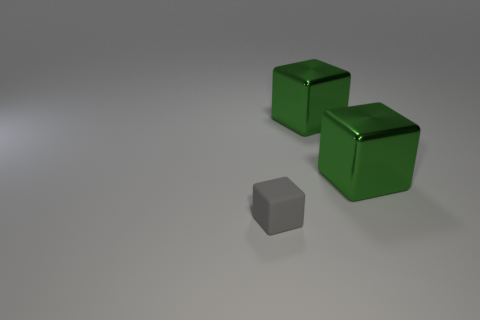Add 3 matte cubes. How many objects exist? 6 Add 2 gray matte blocks. How many gray matte blocks are left? 3 Add 1 tiny gray matte objects. How many tiny gray matte objects exist? 2 Subtract 0 cyan cylinders. How many objects are left? 3 Subtract all rubber things. Subtract all large blocks. How many objects are left? 0 